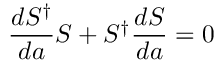Convert formula to latex. <formula><loc_0><loc_0><loc_500><loc_500>\frac { d S ^ { \dagger } } { d a } S + S ^ { \dagger } \frac { d S } { d a } = 0</formula> 